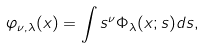<formula> <loc_0><loc_0><loc_500><loc_500>\varphi _ { \nu , \lambda } ( x ) = \int s ^ { \nu } \Phi _ { \lambda } ( x ; s ) d s ,</formula> 